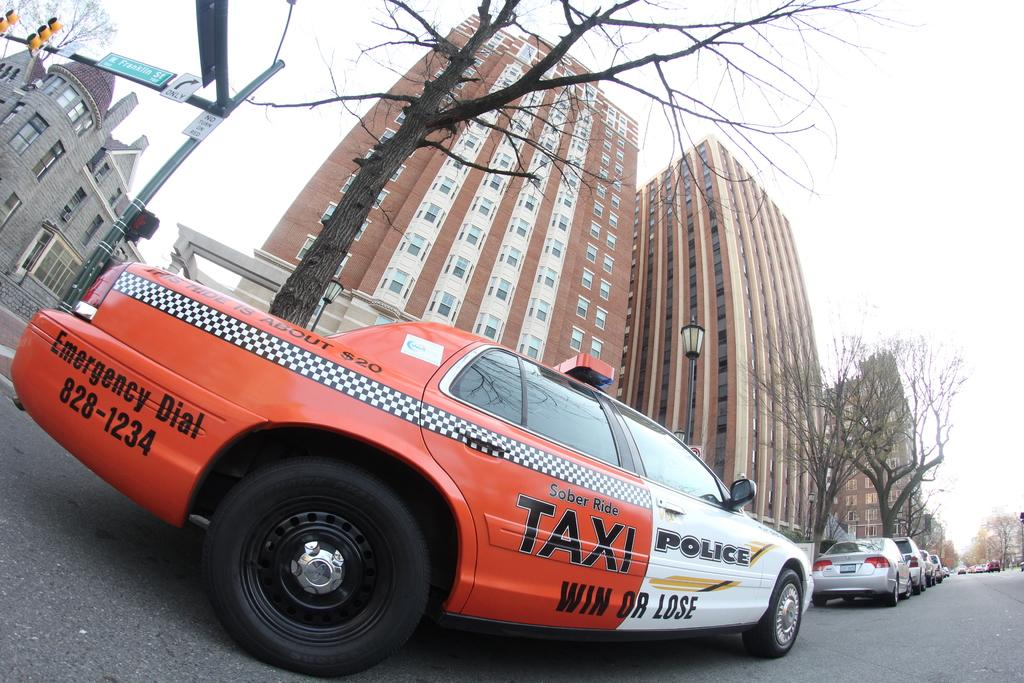<image>
Relay a brief, clear account of the picture shown. A multi colored car is labeled with both TAXI and POLICE and also the phrase WIN OR LOSE. 